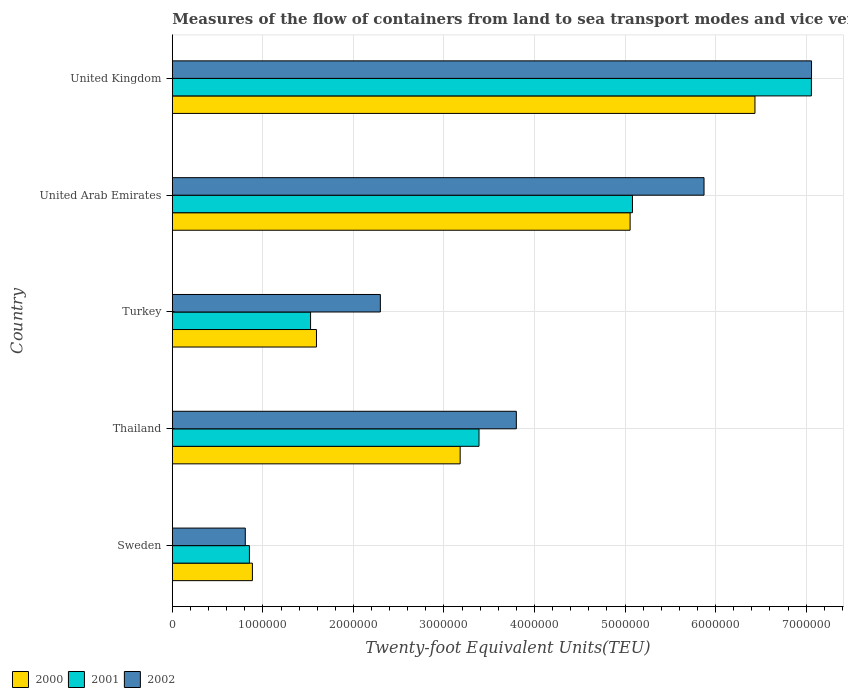How many different coloured bars are there?
Give a very brief answer. 3. How many groups of bars are there?
Make the answer very short. 5. Are the number of bars per tick equal to the number of legend labels?
Your answer should be very brief. Yes. What is the label of the 4th group of bars from the top?
Keep it short and to the point. Thailand. In how many cases, is the number of bars for a given country not equal to the number of legend labels?
Offer a very short reply. 0. What is the container port traffic in 2001 in Turkey?
Your answer should be very brief. 1.53e+06. Across all countries, what is the maximum container port traffic in 2002?
Your answer should be very brief. 7.06e+06. Across all countries, what is the minimum container port traffic in 2000?
Offer a terse response. 8.84e+05. In which country was the container port traffic in 2002 maximum?
Offer a terse response. United Kingdom. What is the total container port traffic in 2000 in the graph?
Your answer should be very brief. 1.71e+07. What is the difference between the container port traffic in 2002 in Sweden and that in United Kingdom?
Give a very brief answer. -6.25e+06. What is the difference between the container port traffic in 2002 in United Kingdom and the container port traffic in 2001 in Thailand?
Offer a terse response. 3.67e+06. What is the average container port traffic in 2002 per country?
Offer a very short reply. 3.97e+06. What is the difference between the container port traffic in 2000 and container port traffic in 2001 in Sweden?
Give a very brief answer. 3.29e+04. In how many countries, is the container port traffic in 2001 greater than 4800000 TEU?
Your response must be concise. 2. What is the ratio of the container port traffic in 2001 in Turkey to that in United Arab Emirates?
Provide a succinct answer. 0.3. Is the difference between the container port traffic in 2000 in Thailand and United Arab Emirates greater than the difference between the container port traffic in 2001 in Thailand and United Arab Emirates?
Give a very brief answer. No. What is the difference between the highest and the second highest container port traffic in 2002?
Your answer should be compact. 1.19e+06. What is the difference between the highest and the lowest container port traffic in 2002?
Ensure brevity in your answer.  6.25e+06. Is the sum of the container port traffic in 2000 in Turkey and United Kingdom greater than the maximum container port traffic in 2001 across all countries?
Give a very brief answer. Yes. What does the 2nd bar from the top in United Arab Emirates represents?
Ensure brevity in your answer.  2001. Is it the case that in every country, the sum of the container port traffic in 2001 and container port traffic in 2000 is greater than the container port traffic in 2002?
Your answer should be very brief. Yes. Are all the bars in the graph horizontal?
Keep it short and to the point. Yes. Are the values on the major ticks of X-axis written in scientific E-notation?
Give a very brief answer. No. Does the graph contain any zero values?
Make the answer very short. No. Does the graph contain grids?
Keep it short and to the point. Yes. Where does the legend appear in the graph?
Provide a short and direct response. Bottom left. What is the title of the graph?
Your answer should be very brief. Measures of the flow of containers from land to sea transport modes and vice versa. Does "2015" appear as one of the legend labels in the graph?
Your response must be concise. No. What is the label or title of the X-axis?
Provide a short and direct response. Twenty-foot Equivalent Units(TEU). What is the label or title of the Y-axis?
Your answer should be very brief. Country. What is the Twenty-foot Equivalent Units(TEU) in 2000 in Sweden?
Your answer should be compact. 8.84e+05. What is the Twenty-foot Equivalent Units(TEU) in 2001 in Sweden?
Make the answer very short. 8.51e+05. What is the Twenty-foot Equivalent Units(TEU) in 2002 in Sweden?
Give a very brief answer. 8.06e+05. What is the Twenty-foot Equivalent Units(TEU) of 2000 in Thailand?
Your answer should be very brief. 3.18e+06. What is the Twenty-foot Equivalent Units(TEU) of 2001 in Thailand?
Make the answer very short. 3.39e+06. What is the Twenty-foot Equivalent Units(TEU) of 2002 in Thailand?
Give a very brief answer. 3.80e+06. What is the Twenty-foot Equivalent Units(TEU) in 2000 in Turkey?
Offer a terse response. 1.59e+06. What is the Twenty-foot Equivalent Units(TEU) in 2001 in Turkey?
Your answer should be compact. 1.53e+06. What is the Twenty-foot Equivalent Units(TEU) of 2002 in Turkey?
Offer a terse response. 2.30e+06. What is the Twenty-foot Equivalent Units(TEU) in 2000 in United Arab Emirates?
Your answer should be very brief. 5.06e+06. What is the Twenty-foot Equivalent Units(TEU) in 2001 in United Arab Emirates?
Ensure brevity in your answer.  5.08e+06. What is the Twenty-foot Equivalent Units(TEU) in 2002 in United Arab Emirates?
Ensure brevity in your answer.  5.87e+06. What is the Twenty-foot Equivalent Units(TEU) in 2000 in United Kingdom?
Provide a short and direct response. 6.43e+06. What is the Twenty-foot Equivalent Units(TEU) in 2001 in United Kingdom?
Offer a very short reply. 7.06e+06. What is the Twenty-foot Equivalent Units(TEU) of 2002 in United Kingdom?
Give a very brief answer. 7.06e+06. Across all countries, what is the maximum Twenty-foot Equivalent Units(TEU) of 2000?
Offer a terse response. 6.43e+06. Across all countries, what is the maximum Twenty-foot Equivalent Units(TEU) of 2001?
Make the answer very short. 7.06e+06. Across all countries, what is the maximum Twenty-foot Equivalent Units(TEU) of 2002?
Offer a very short reply. 7.06e+06. Across all countries, what is the minimum Twenty-foot Equivalent Units(TEU) of 2000?
Keep it short and to the point. 8.84e+05. Across all countries, what is the minimum Twenty-foot Equivalent Units(TEU) in 2001?
Give a very brief answer. 8.51e+05. Across all countries, what is the minimum Twenty-foot Equivalent Units(TEU) of 2002?
Keep it short and to the point. 8.06e+05. What is the total Twenty-foot Equivalent Units(TEU) of 2000 in the graph?
Give a very brief answer. 1.71e+07. What is the total Twenty-foot Equivalent Units(TEU) of 2001 in the graph?
Your answer should be compact. 1.79e+07. What is the total Twenty-foot Equivalent Units(TEU) in 2002 in the graph?
Keep it short and to the point. 1.98e+07. What is the difference between the Twenty-foot Equivalent Units(TEU) of 2000 in Sweden and that in Thailand?
Offer a very short reply. -2.29e+06. What is the difference between the Twenty-foot Equivalent Units(TEU) of 2001 in Sweden and that in Thailand?
Make the answer very short. -2.54e+06. What is the difference between the Twenty-foot Equivalent Units(TEU) in 2002 in Sweden and that in Thailand?
Offer a terse response. -2.99e+06. What is the difference between the Twenty-foot Equivalent Units(TEU) in 2000 in Sweden and that in Turkey?
Provide a short and direct response. -7.08e+05. What is the difference between the Twenty-foot Equivalent Units(TEU) of 2001 in Sweden and that in Turkey?
Ensure brevity in your answer.  -6.75e+05. What is the difference between the Twenty-foot Equivalent Units(TEU) of 2002 in Sweden and that in Turkey?
Your response must be concise. -1.49e+06. What is the difference between the Twenty-foot Equivalent Units(TEU) in 2000 in Sweden and that in United Arab Emirates?
Provide a succinct answer. -4.17e+06. What is the difference between the Twenty-foot Equivalent Units(TEU) in 2001 in Sweden and that in United Arab Emirates?
Provide a succinct answer. -4.23e+06. What is the difference between the Twenty-foot Equivalent Units(TEU) of 2002 in Sweden and that in United Arab Emirates?
Ensure brevity in your answer.  -5.07e+06. What is the difference between the Twenty-foot Equivalent Units(TEU) of 2000 in Sweden and that in United Kingdom?
Provide a short and direct response. -5.55e+06. What is the difference between the Twenty-foot Equivalent Units(TEU) of 2001 in Sweden and that in United Kingdom?
Offer a very short reply. -6.21e+06. What is the difference between the Twenty-foot Equivalent Units(TEU) in 2002 in Sweden and that in United Kingdom?
Your response must be concise. -6.25e+06. What is the difference between the Twenty-foot Equivalent Units(TEU) in 2000 in Thailand and that in Turkey?
Your answer should be compact. 1.59e+06. What is the difference between the Twenty-foot Equivalent Units(TEU) in 2001 in Thailand and that in Turkey?
Offer a terse response. 1.86e+06. What is the difference between the Twenty-foot Equivalent Units(TEU) in 2002 in Thailand and that in Turkey?
Offer a very short reply. 1.50e+06. What is the difference between the Twenty-foot Equivalent Units(TEU) of 2000 in Thailand and that in United Arab Emirates?
Keep it short and to the point. -1.88e+06. What is the difference between the Twenty-foot Equivalent Units(TEU) in 2001 in Thailand and that in United Arab Emirates?
Ensure brevity in your answer.  -1.69e+06. What is the difference between the Twenty-foot Equivalent Units(TEU) of 2002 in Thailand and that in United Arab Emirates?
Your answer should be compact. -2.07e+06. What is the difference between the Twenty-foot Equivalent Units(TEU) in 2000 in Thailand and that in United Kingdom?
Offer a very short reply. -3.26e+06. What is the difference between the Twenty-foot Equivalent Units(TEU) in 2001 in Thailand and that in United Kingdom?
Offer a very short reply. -3.67e+06. What is the difference between the Twenty-foot Equivalent Units(TEU) of 2002 in Thailand and that in United Kingdom?
Make the answer very short. -3.26e+06. What is the difference between the Twenty-foot Equivalent Units(TEU) in 2000 in Turkey and that in United Arab Emirates?
Provide a succinct answer. -3.46e+06. What is the difference between the Twenty-foot Equivalent Units(TEU) in 2001 in Turkey and that in United Arab Emirates?
Offer a very short reply. -3.56e+06. What is the difference between the Twenty-foot Equivalent Units(TEU) of 2002 in Turkey and that in United Arab Emirates?
Provide a short and direct response. -3.57e+06. What is the difference between the Twenty-foot Equivalent Units(TEU) in 2000 in Turkey and that in United Kingdom?
Give a very brief answer. -4.84e+06. What is the difference between the Twenty-foot Equivalent Units(TEU) of 2001 in Turkey and that in United Kingdom?
Provide a short and direct response. -5.53e+06. What is the difference between the Twenty-foot Equivalent Units(TEU) of 2002 in Turkey and that in United Kingdom?
Your answer should be very brief. -4.76e+06. What is the difference between the Twenty-foot Equivalent Units(TEU) in 2000 in United Arab Emirates and that in United Kingdom?
Your answer should be compact. -1.38e+06. What is the difference between the Twenty-foot Equivalent Units(TEU) of 2001 in United Arab Emirates and that in United Kingdom?
Ensure brevity in your answer.  -1.98e+06. What is the difference between the Twenty-foot Equivalent Units(TEU) of 2002 in United Arab Emirates and that in United Kingdom?
Keep it short and to the point. -1.19e+06. What is the difference between the Twenty-foot Equivalent Units(TEU) in 2000 in Sweden and the Twenty-foot Equivalent Units(TEU) in 2001 in Thailand?
Make the answer very short. -2.50e+06. What is the difference between the Twenty-foot Equivalent Units(TEU) of 2000 in Sweden and the Twenty-foot Equivalent Units(TEU) of 2002 in Thailand?
Provide a short and direct response. -2.91e+06. What is the difference between the Twenty-foot Equivalent Units(TEU) in 2001 in Sweden and the Twenty-foot Equivalent Units(TEU) in 2002 in Thailand?
Provide a short and direct response. -2.95e+06. What is the difference between the Twenty-foot Equivalent Units(TEU) of 2000 in Sweden and the Twenty-foot Equivalent Units(TEU) of 2001 in Turkey?
Your answer should be compact. -6.42e+05. What is the difference between the Twenty-foot Equivalent Units(TEU) of 2000 in Sweden and the Twenty-foot Equivalent Units(TEU) of 2002 in Turkey?
Offer a terse response. -1.41e+06. What is the difference between the Twenty-foot Equivalent Units(TEU) of 2001 in Sweden and the Twenty-foot Equivalent Units(TEU) of 2002 in Turkey?
Keep it short and to the point. -1.45e+06. What is the difference between the Twenty-foot Equivalent Units(TEU) in 2000 in Sweden and the Twenty-foot Equivalent Units(TEU) in 2001 in United Arab Emirates?
Ensure brevity in your answer.  -4.20e+06. What is the difference between the Twenty-foot Equivalent Units(TEU) in 2000 in Sweden and the Twenty-foot Equivalent Units(TEU) in 2002 in United Arab Emirates?
Provide a succinct answer. -4.99e+06. What is the difference between the Twenty-foot Equivalent Units(TEU) in 2001 in Sweden and the Twenty-foot Equivalent Units(TEU) in 2002 in United Arab Emirates?
Keep it short and to the point. -5.02e+06. What is the difference between the Twenty-foot Equivalent Units(TEU) in 2000 in Sweden and the Twenty-foot Equivalent Units(TEU) in 2001 in United Kingdom?
Your answer should be compact. -6.17e+06. What is the difference between the Twenty-foot Equivalent Units(TEU) in 2000 in Sweden and the Twenty-foot Equivalent Units(TEU) in 2002 in United Kingdom?
Give a very brief answer. -6.18e+06. What is the difference between the Twenty-foot Equivalent Units(TEU) in 2001 in Sweden and the Twenty-foot Equivalent Units(TEU) in 2002 in United Kingdom?
Your response must be concise. -6.21e+06. What is the difference between the Twenty-foot Equivalent Units(TEU) in 2000 in Thailand and the Twenty-foot Equivalent Units(TEU) in 2001 in Turkey?
Make the answer very short. 1.65e+06. What is the difference between the Twenty-foot Equivalent Units(TEU) of 2000 in Thailand and the Twenty-foot Equivalent Units(TEU) of 2002 in Turkey?
Provide a short and direct response. 8.81e+05. What is the difference between the Twenty-foot Equivalent Units(TEU) of 2001 in Thailand and the Twenty-foot Equivalent Units(TEU) of 2002 in Turkey?
Your response must be concise. 1.09e+06. What is the difference between the Twenty-foot Equivalent Units(TEU) of 2000 in Thailand and the Twenty-foot Equivalent Units(TEU) of 2001 in United Arab Emirates?
Your response must be concise. -1.90e+06. What is the difference between the Twenty-foot Equivalent Units(TEU) in 2000 in Thailand and the Twenty-foot Equivalent Units(TEU) in 2002 in United Arab Emirates?
Your response must be concise. -2.69e+06. What is the difference between the Twenty-foot Equivalent Units(TEU) in 2001 in Thailand and the Twenty-foot Equivalent Units(TEU) in 2002 in United Arab Emirates?
Keep it short and to the point. -2.49e+06. What is the difference between the Twenty-foot Equivalent Units(TEU) in 2000 in Thailand and the Twenty-foot Equivalent Units(TEU) in 2001 in United Kingdom?
Your answer should be compact. -3.88e+06. What is the difference between the Twenty-foot Equivalent Units(TEU) of 2000 in Thailand and the Twenty-foot Equivalent Units(TEU) of 2002 in United Kingdom?
Ensure brevity in your answer.  -3.88e+06. What is the difference between the Twenty-foot Equivalent Units(TEU) of 2001 in Thailand and the Twenty-foot Equivalent Units(TEU) of 2002 in United Kingdom?
Offer a very short reply. -3.67e+06. What is the difference between the Twenty-foot Equivalent Units(TEU) of 2000 in Turkey and the Twenty-foot Equivalent Units(TEU) of 2001 in United Arab Emirates?
Keep it short and to the point. -3.49e+06. What is the difference between the Twenty-foot Equivalent Units(TEU) in 2000 in Turkey and the Twenty-foot Equivalent Units(TEU) in 2002 in United Arab Emirates?
Your answer should be very brief. -4.28e+06. What is the difference between the Twenty-foot Equivalent Units(TEU) in 2001 in Turkey and the Twenty-foot Equivalent Units(TEU) in 2002 in United Arab Emirates?
Ensure brevity in your answer.  -4.35e+06. What is the difference between the Twenty-foot Equivalent Units(TEU) of 2000 in Turkey and the Twenty-foot Equivalent Units(TEU) of 2001 in United Kingdom?
Ensure brevity in your answer.  -5.47e+06. What is the difference between the Twenty-foot Equivalent Units(TEU) in 2000 in Turkey and the Twenty-foot Equivalent Units(TEU) in 2002 in United Kingdom?
Your answer should be compact. -5.47e+06. What is the difference between the Twenty-foot Equivalent Units(TEU) of 2001 in Turkey and the Twenty-foot Equivalent Units(TEU) of 2002 in United Kingdom?
Offer a terse response. -5.53e+06. What is the difference between the Twenty-foot Equivalent Units(TEU) of 2000 in United Arab Emirates and the Twenty-foot Equivalent Units(TEU) of 2001 in United Kingdom?
Provide a succinct answer. -2.00e+06. What is the difference between the Twenty-foot Equivalent Units(TEU) in 2000 in United Arab Emirates and the Twenty-foot Equivalent Units(TEU) in 2002 in United Kingdom?
Make the answer very short. -2.00e+06. What is the difference between the Twenty-foot Equivalent Units(TEU) of 2001 in United Arab Emirates and the Twenty-foot Equivalent Units(TEU) of 2002 in United Kingdom?
Provide a short and direct response. -1.98e+06. What is the average Twenty-foot Equivalent Units(TEU) in 2000 per country?
Offer a very short reply. 3.43e+06. What is the average Twenty-foot Equivalent Units(TEU) of 2001 per country?
Provide a short and direct response. 3.58e+06. What is the average Twenty-foot Equivalent Units(TEU) in 2002 per country?
Provide a short and direct response. 3.97e+06. What is the difference between the Twenty-foot Equivalent Units(TEU) in 2000 and Twenty-foot Equivalent Units(TEU) in 2001 in Sweden?
Provide a succinct answer. 3.29e+04. What is the difference between the Twenty-foot Equivalent Units(TEU) in 2000 and Twenty-foot Equivalent Units(TEU) in 2002 in Sweden?
Offer a very short reply. 7.85e+04. What is the difference between the Twenty-foot Equivalent Units(TEU) in 2001 and Twenty-foot Equivalent Units(TEU) in 2002 in Sweden?
Make the answer very short. 4.56e+04. What is the difference between the Twenty-foot Equivalent Units(TEU) in 2000 and Twenty-foot Equivalent Units(TEU) in 2001 in Thailand?
Give a very brief answer. -2.08e+05. What is the difference between the Twenty-foot Equivalent Units(TEU) of 2000 and Twenty-foot Equivalent Units(TEU) of 2002 in Thailand?
Keep it short and to the point. -6.20e+05. What is the difference between the Twenty-foot Equivalent Units(TEU) of 2001 and Twenty-foot Equivalent Units(TEU) of 2002 in Thailand?
Your answer should be very brief. -4.12e+05. What is the difference between the Twenty-foot Equivalent Units(TEU) in 2000 and Twenty-foot Equivalent Units(TEU) in 2001 in Turkey?
Provide a short and direct response. 6.52e+04. What is the difference between the Twenty-foot Equivalent Units(TEU) of 2000 and Twenty-foot Equivalent Units(TEU) of 2002 in Turkey?
Your response must be concise. -7.06e+05. What is the difference between the Twenty-foot Equivalent Units(TEU) in 2001 and Twenty-foot Equivalent Units(TEU) in 2002 in Turkey?
Keep it short and to the point. -7.71e+05. What is the difference between the Twenty-foot Equivalent Units(TEU) of 2000 and Twenty-foot Equivalent Units(TEU) of 2001 in United Arab Emirates?
Your answer should be very brief. -2.62e+04. What is the difference between the Twenty-foot Equivalent Units(TEU) in 2000 and Twenty-foot Equivalent Units(TEU) in 2002 in United Arab Emirates?
Provide a short and direct response. -8.16e+05. What is the difference between the Twenty-foot Equivalent Units(TEU) of 2001 and Twenty-foot Equivalent Units(TEU) of 2002 in United Arab Emirates?
Keep it short and to the point. -7.90e+05. What is the difference between the Twenty-foot Equivalent Units(TEU) of 2000 and Twenty-foot Equivalent Units(TEU) of 2001 in United Kingdom?
Make the answer very short. -6.23e+05. What is the difference between the Twenty-foot Equivalent Units(TEU) of 2000 and Twenty-foot Equivalent Units(TEU) of 2002 in United Kingdom?
Provide a succinct answer. -6.25e+05. What is the difference between the Twenty-foot Equivalent Units(TEU) in 2001 and Twenty-foot Equivalent Units(TEU) in 2002 in United Kingdom?
Make the answer very short. -1556. What is the ratio of the Twenty-foot Equivalent Units(TEU) of 2000 in Sweden to that in Thailand?
Keep it short and to the point. 0.28. What is the ratio of the Twenty-foot Equivalent Units(TEU) of 2001 in Sweden to that in Thailand?
Your answer should be very brief. 0.25. What is the ratio of the Twenty-foot Equivalent Units(TEU) in 2002 in Sweden to that in Thailand?
Your answer should be compact. 0.21. What is the ratio of the Twenty-foot Equivalent Units(TEU) in 2000 in Sweden to that in Turkey?
Provide a short and direct response. 0.56. What is the ratio of the Twenty-foot Equivalent Units(TEU) in 2001 in Sweden to that in Turkey?
Offer a terse response. 0.56. What is the ratio of the Twenty-foot Equivalent Units(TEU) in 2002 in Sweden to that in Turkey?
Provide a succinct answer. 0.35. What is the ratio of the Twenty-foot Equivalent Units(TEU) in 2000 in Sweden to that in United Arab Emirates?
Give a very brief answer. 0.17. What is the ratio of the Twenty-foot Equivalent Units(TEU) of 2001 in Sweden to that in United Arab Emirates?
Provide a short and direct response. 0.17. What is the ratio of the Twenty-foot Equivalent Units(TEU) of 2002 in Sweden to that in United Arab Emirates?
Make the answer very short. 0.14. What is the ratio of the Twenty-foot Equivalent Units(TEU) in 2000 in Sweden to that in United Kingdom?
Offer a terse response. 0.14. What is the ratio of the Twenty-foot Equivalent Units(TEU) of 2001 in Sweden to that in United Kingdom?
Make the answer very short. 0.12. What is the ratio of the Twenty-foot Equivalent Units(TEU) in 2002 in Sweden to that in United Kingdom?
Provide a short and direct response. 0.11. What is the ratio of the Twenty-foot Equivalent Units(TEU) of 2000 in Thailand to that in Turkey?
Offer a terse response. 2. What is the ratio of the Twenty-foot Equivalent Units(TEU) in 2001 in Thailand to that in Turkey?
Your response must be concise. 2.22. What is the ratio of the Twenty-foot Equivalent Units(TEU) in 2002 in Thailand to that in Turkey?
Your answer should be compact. 1.65. What is the ratio of the Twenty-foot Equivalent Units(TEU) in 2000 in Thailand to that in United Arab Emirates?
Your answer should be compact. 0.63. What is the ratio of the Twenty-foot Equivalent Units(TEU) in 2001 in Thailand to that in United Arab Emirates?
Ensure brevity in your answer.  0.67. What is the ratio of the Twenty-foot Equivalent Units(TEU) in 2002 in Thailand to that in United Arab Emirates?
Keep it short and to the point. 0.65. What is the ratio of the Twenty-foot Equivalent Units(TEU) of 2000 in Thailand to that in United Kingdom?
Make the answer very short. 0.49. What is the ratio of the Twenty-foot Equivalent Units(TEU) of 2001 in Thailand to that in United Kingdom?
Provide a short and direct response. 0.48. What is the ratio of the Twenty-foot Equivalent Units(TEU) of 2002 in Thailand to that in United Kingdom?
Keep it short and to the point. 0.54. What is the ratio of the Twenty-foot Equivalent Units(TEU) of 2000 in Turkey to that in United Arab Emirates?
Your answer should be very brief. 0.31. What is the ratio of the Twenty-foot Equivalent Units(TEU) of 2001 in Turkey to that in United Arab Emirates?
Offer a terse response. 0.3. What is the ratio of the Twenty-foot Equivalent Units(TEU) of 2002 in Turkey to that in United Arab Emirates?
Offer a very short reply. 0.39. What is the ratio of the Twenty-foot Equivalent Units(TEU) in 2000 in Turkey to that in United Kingdom?
Your response must be concise. 0.25. What is the ratio of the Twenty-foot Equivalent Units(TEU) in 2001 in Turkey to that in United Kingdom?
Give a very brief answer. 0.22. What is the ratio of the Twenty-foot Equivalent Units(TEU) in 2002 in Turkey to that in United Kingdom?
Keep it short and to the point. 0.33. What is the ratio of the Twenty-foot Equivalent Units(TEU) in 2000 in United Arab Emirates to that in United Kingdom?
Offer a terse response. 0.79. What is the ratio of the Twenty-foot Equivalent Units(TEU) of 2001 in United Arab Emirates to that in United Kingdom?
Offer a very short reply. 0.72. What is the ratio of the Twenty-foot Equivalent Units(TEU) of 2002 in United Arab Emirates to that in United Kingdom?
Your response must be concise. 0.83. What is the difference between the highest and the second highest Twenty-foot Equivalent Units(TEU) in 2000?
Your response must be concise. 1.38e+06. What is the difference between the highest and the second highest Twenty-foot Equivalent Units(TEU) of 2001?
Offer a terse response. 1.98e+06. What is the difference between the highest and the second highest Twenty-foot Equivalent Units(TEU) of 2002?
Your response must be concise. 1.19e+06. What is the difference between the highest and the lowest Twenty-foot Equivalent Units(TEU) in 2000?
Offer a terse response. 5.55e+06. What is the difference between the highest and the lowest Twenty-foot Equivalent Units(TEU) in 2001?
Make the answer very short. 6.21e+06. What is the difference between the highest and the lowest Twenty-foot Equivalent Units(TEU) in 2002?
Make the answer very short. 6.25e+06. 